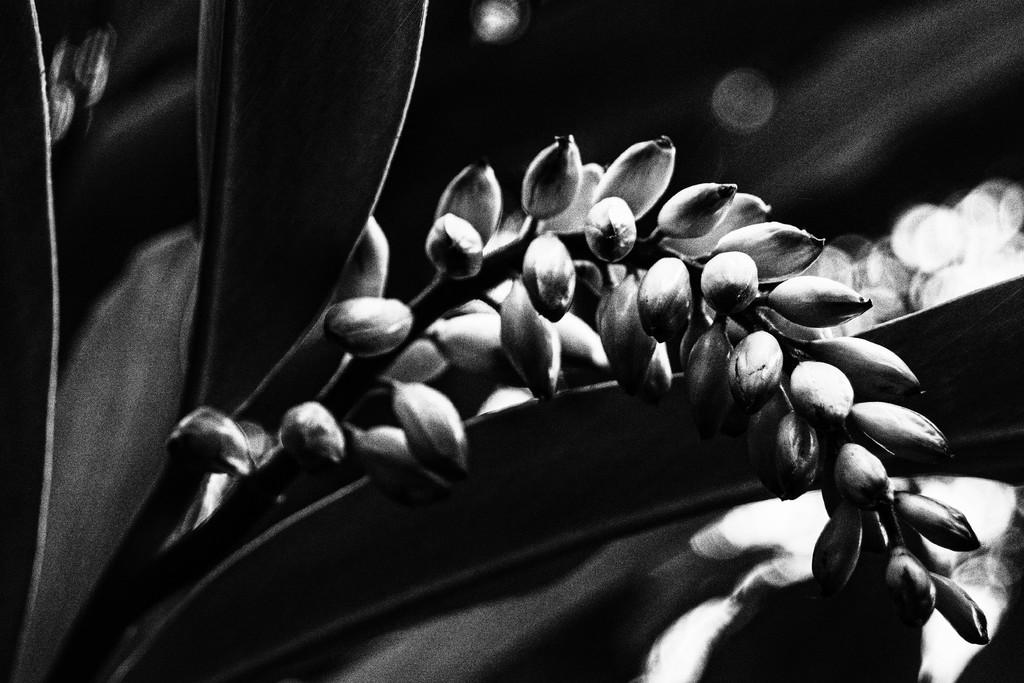What is the color scheme of the image? The image is black and white. What type of plants can be seen in the image? There are flowers and leaves in the image. What color is the background of the image? The background of the image is black. What type of clock is visible in the image? There is no clock present in the image. What property is being sold in the image? There is no property being sold in the image; it features flowers and leaves. 